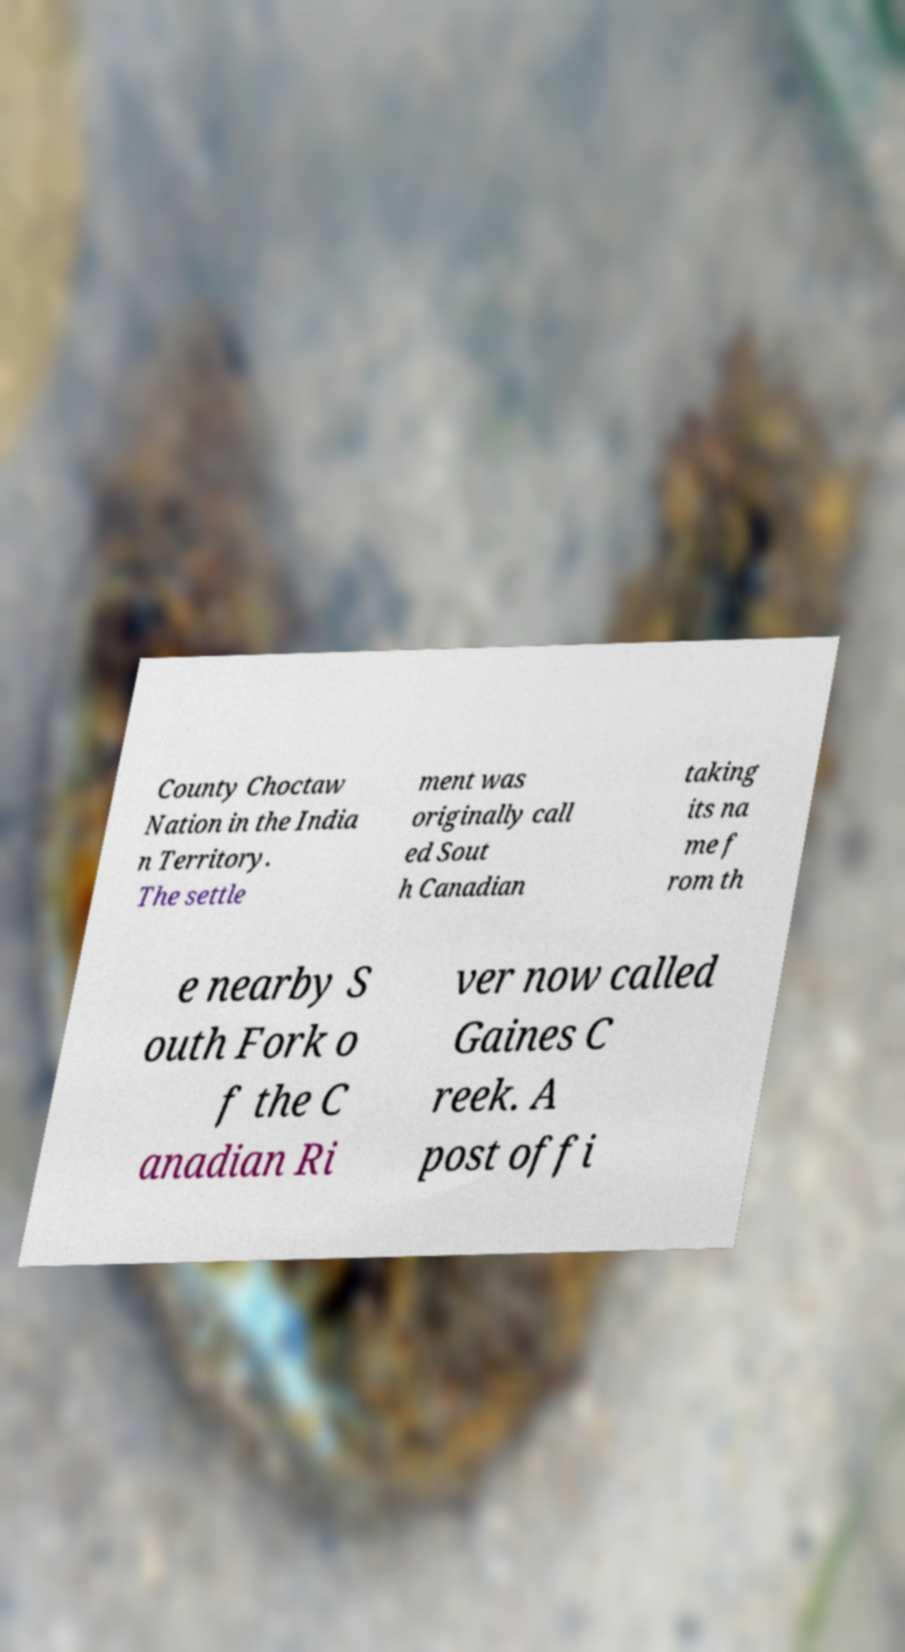Could you assist in decoding the text presented in this image and type it out clearly? County Choctaw Nation in the India n Territory. The settle ment was originally call ed Sout h Canadian taking its na me f rom th e nearby S outh Fork o f the C anadian Ri ver now called Gaines C reek. A post offi 